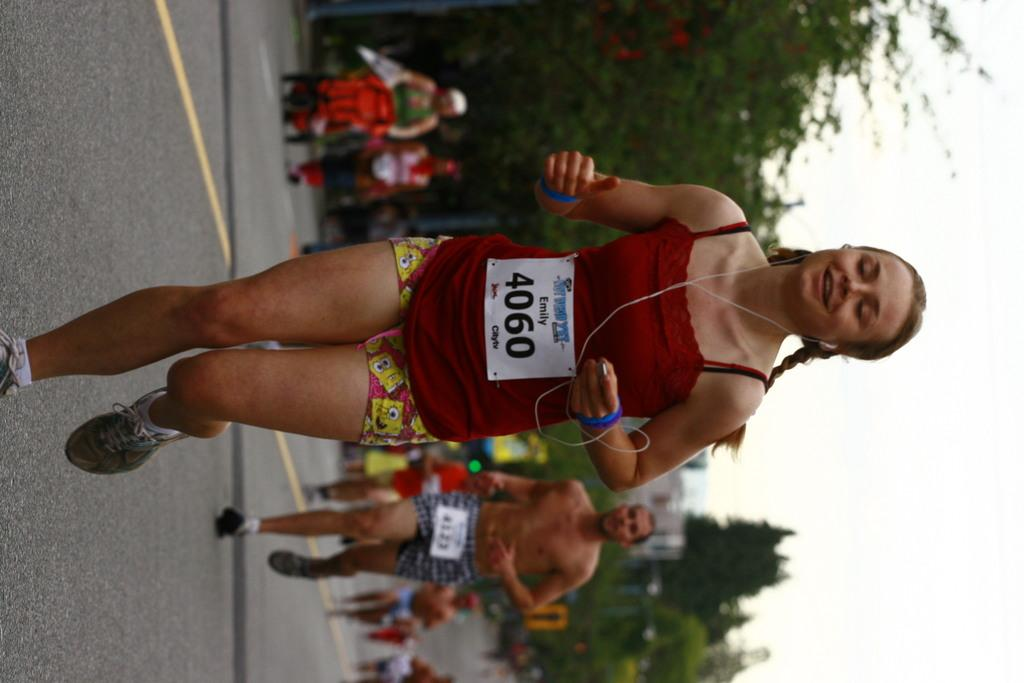Provide a one-sentence caption for the provided image. A runner named Emily and number 4060 runs on the street,. 